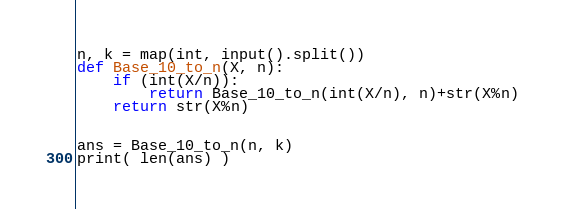<code> <loc_0><loc_0><loc_500><loc_500><_Python_>n, k = map(int, input().split())
def Base_10_to_n(X, n):
    if (int(X/n)):
        return Base_10_to_n(int(X/n), n)+str(X%n)
    return str(X%n)


ans = Base_10_to_n(n, k)
print( len(ans) )</code> 